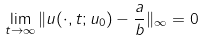Convert formula to latex. <formula><loc_0><loc_0><loc_500><loc_500>\lim _ { t \to \infty } \| u ( \cdot , t ; u _ { 0 } ) - \frac { a } { b } \| _ { \infty } = 0</formula> 